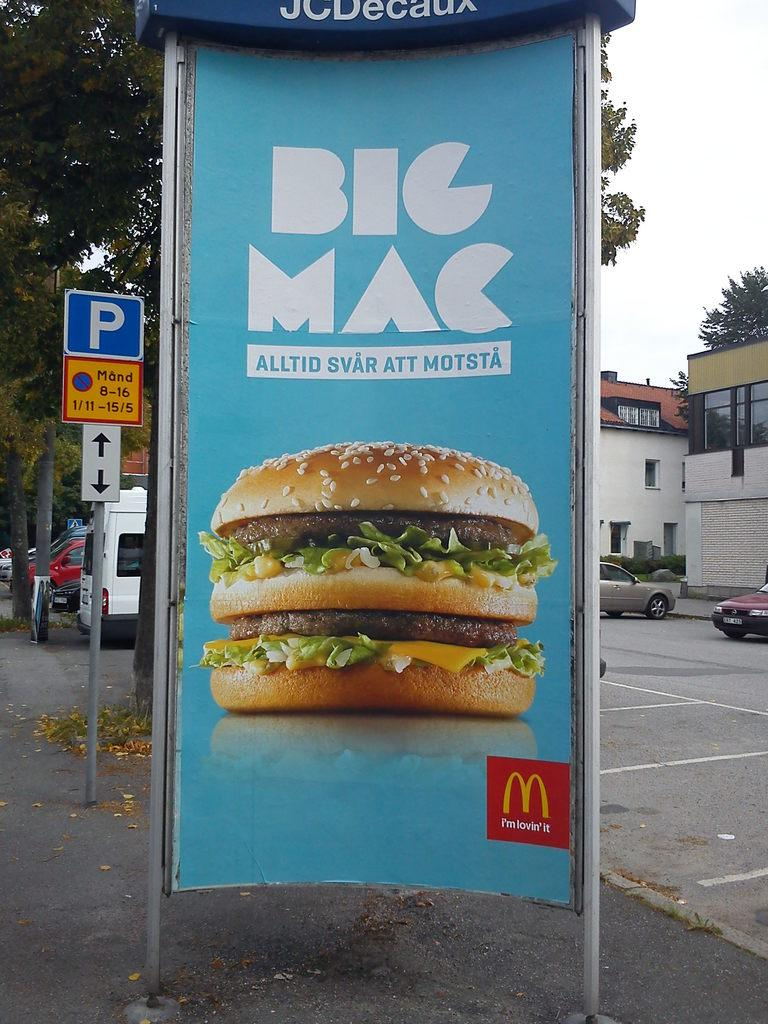What type of sign poles are visible in the image? There is a boarding sign pole and a parking sign pole in the image. What is the purpose of the parking sign pole? The parking sign pole indicates the presence of a parking area. Can you describe the parking area in the image? Cars are parked in the parking area in the image. What can be seen in the background of the image? There are trees and houses in the background of the image. What type of food is being prepared in the image? There is no food preparation visible in the image; it features sign poles, a parking area, and background elements. 